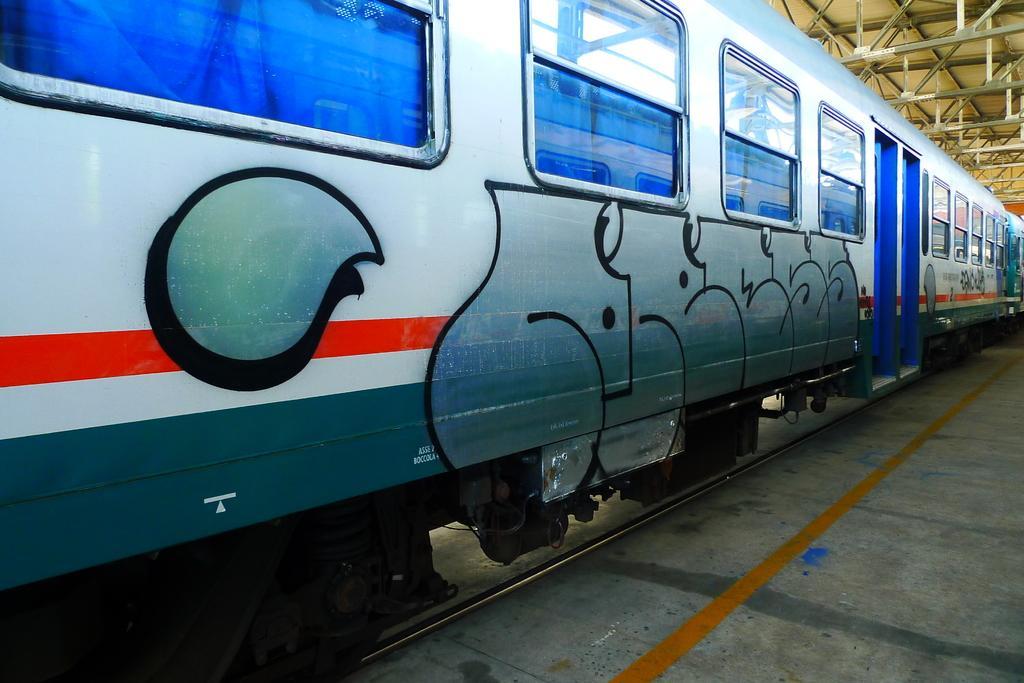Please provide a concise description of this image. In the center of the image we can see one train on the track. And we can see some design on the train. In the background there is a roof and a few other objects. 